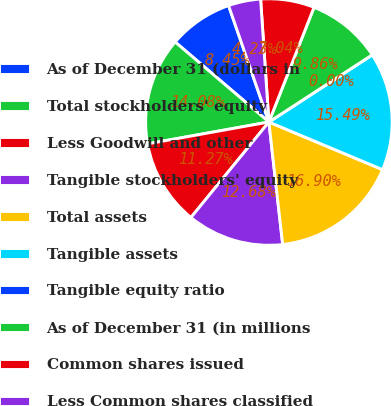<chart> <loc_0><loc_0><loc_500><loc_500><pie_chart><fcel>As of December 31 (dollars in<fcel>Total stockholders' equity<fcel>Less Goodwill and other<fcel>Tangible stockholders' equity<fcel>Total assets<fcel>Tangible assets<fcel>Tangible equity ratio<fcel>As of December 31 (in millions<fcel>Common shares issued<fcel>Less Common shares classified<nl><fcel>8.45%<fcel>14.08%<fcel>11.27%<fcel>12.68%<fcel>16.9%<fcel>15.49%<fcel>0.0%<fcel>9.86%<fcel>7.04%<fcel>4.23%<nl></chart> 